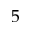Convert formula to latex. <formula><loc_0><loc_0><loc_500><loc_500>5</formula> 